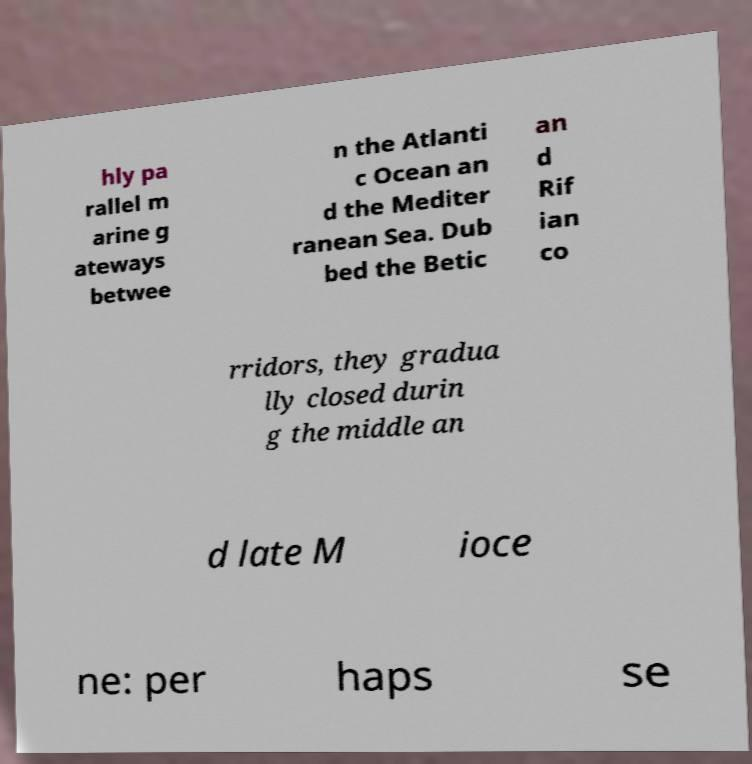Please identify and transcribe the text found in this image. hly pa rallel m arine g ateways betwee n the Atlanti c Ocean an d the Mediter ranean Sea. Dub bed the Betic an d Rif ian co rridors, they gradua lly closed durin g the middle an d late M ioce ne: per haps se 